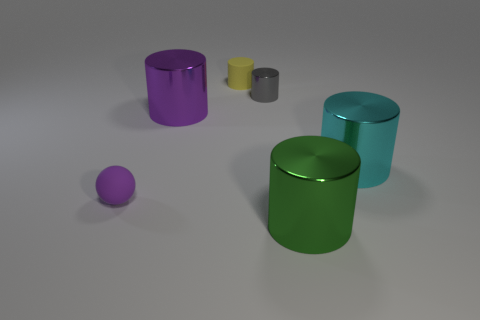What is the material that these objects appear to be made of? The objects in the image seem to have a smooth, reflective surface, which suggests they are likely made of a metal or a plastic material with a metallic paint finish. 